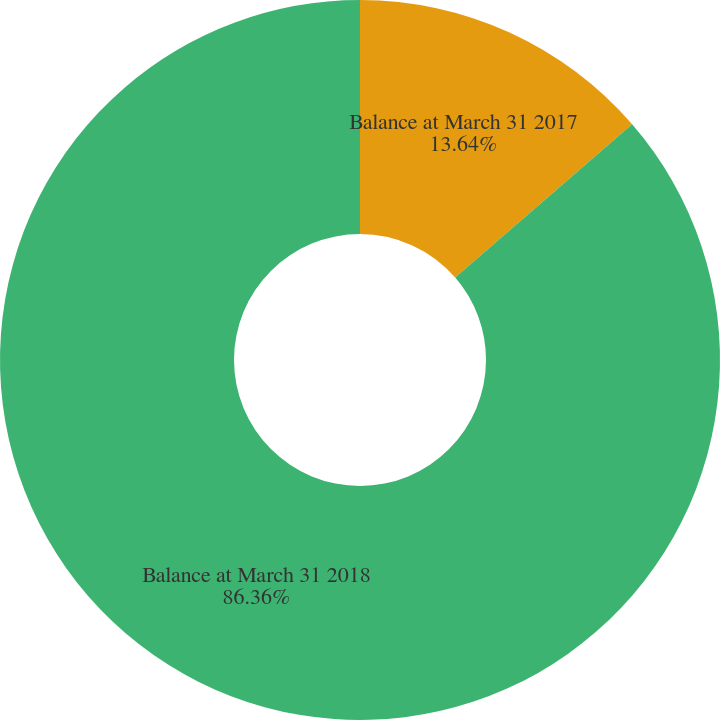Convert chart to OTSL. <chart><loc_0><loc_0><loc_500><loc_500><pie_chart><fcel>Balance at March 31 2017<fcel>Balance at March 31 2018<nl><fcel>13.64%<fcel>86.36%<nl></chart> 